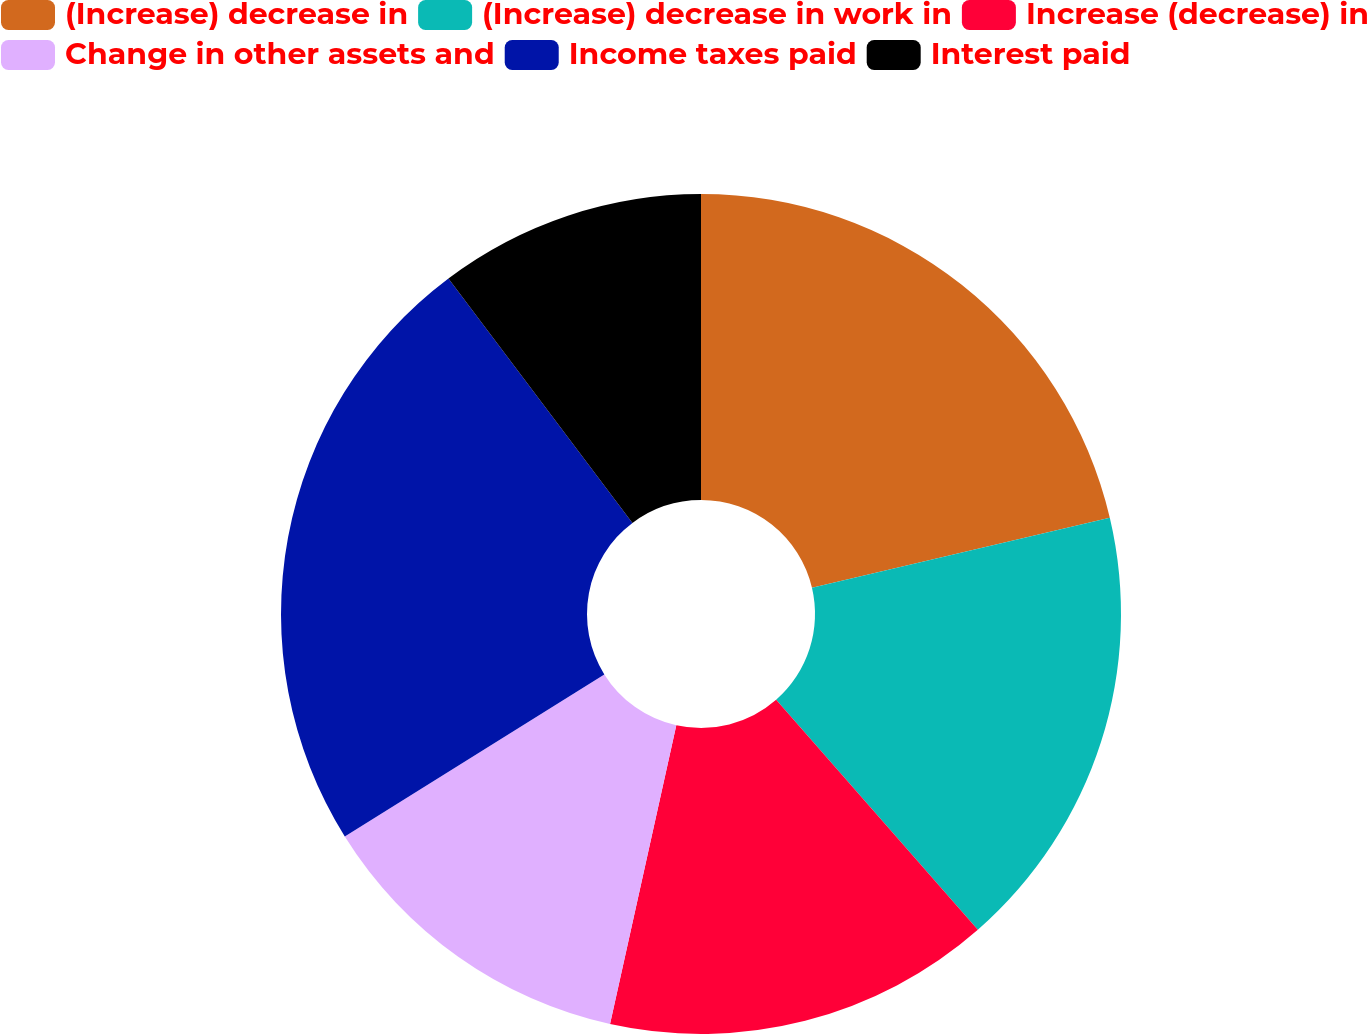Convert chart to OTSL. <chart><loc_0><loc_0><loc_500><loc_500><pie_chart><fcel>(Increase) decrease in<fcel>(Increase) decrease in work in<fcel>Increase (decrease) in<fcel>Change in other assets and<fcel>Income taxes paid<fcel>Interest paid<nl><fcel>21.32%<fcel>17.23%<fcel>14.93%<fcel>12.64%<fcel>23.62%<fcel>10.27%<nl></chart> 